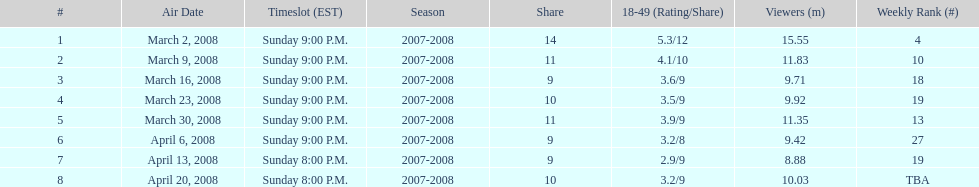The air date with the most viewers March 2, 2008. Would you be able to parse every entry in this table? {'header': ['#', 'Air Date', 'Timeslot (EST)', 'Season', 'Share', '18-49 (Rating/Share)', 'Viewers (m)', 'Weekly Rank (#)'], 'rows': [['1', 'March 2, 2008', 'Sunday 9:00 P.M.', '2007-2008', '14', '5.3/12', '15.55', '4'], ['2', 'March 9, 2008', 'Sunday 9:00 P.M.', '2007-2008', '11', '4.1/10', '11.83', '10'], ['3', 'March 16, 2008', 'Sunday 9:00 P.M.', '2007-2008', '9', '3.6/9', '9.71', '18'], ['4', 'March 23, 2008', 'Sunday 9:00 P.M.', '2007-2008', '10', '3.5/9', '9.92', '19'], ['5', 'March 30, 2008', 'Sunday 9:00 P.M.', '2007-2008', '11', '3.9/9', '11.35', '13'], ['6', 'April 6, 2008', 'Sunday 9:00 P.M.', '2007-2008', '9', '3.2/8', '9.42', '27'], ['7', 'April 13, 2008', 'Sunday 8:00 P.M.', '2007-2008', '9', '2.9/9', '8.88', '19'], ['8', 'April 20, 2008', 'Sunday 8:00 P.M.', '2007-2008', '10', '3.2/9', '10.03', 'TBA']]} 